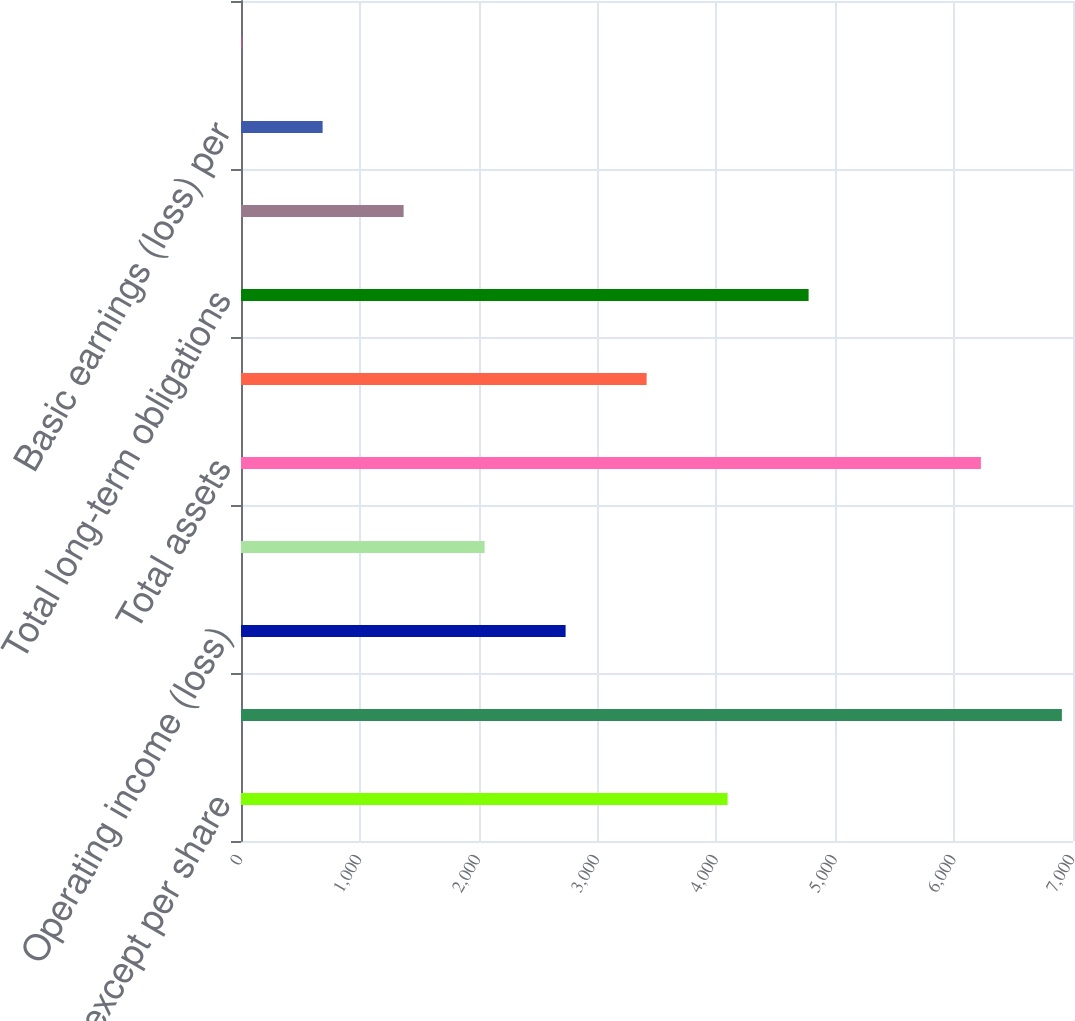Convert chart. <chart><loc_0><loc_0><loc_500><loc_500><bar_chart><fcel>( in millions except per share<fcel>Sales and service revenues<fcel>Operating income (loss)<fcel>Net earnings (loss)<fcel>Total assets<fcel>Long-term debt (1)<fcel>Total long-term obligations<fcel>Free cash flow (2)<fcel>Basic earnings (loss) per<fcel>Diluted earnings (loss) per<nl><fcel>4094.06<fcel>6906.48<fcel>2731.1<fcel>2049.62<fcel>6225<fcel>3412.58<fcel>4775.54<fcel>1368.14<fcel>686.66<fcel>5.18<nl></chart> 